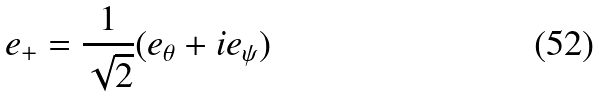<formula> <loc_0><loc_0><loc_500><loc_500>e _ { + } = \frac { 1 } { \sqrt { 2 } } ( e _ { \theta } + i e _ { \psi } )</formula> 